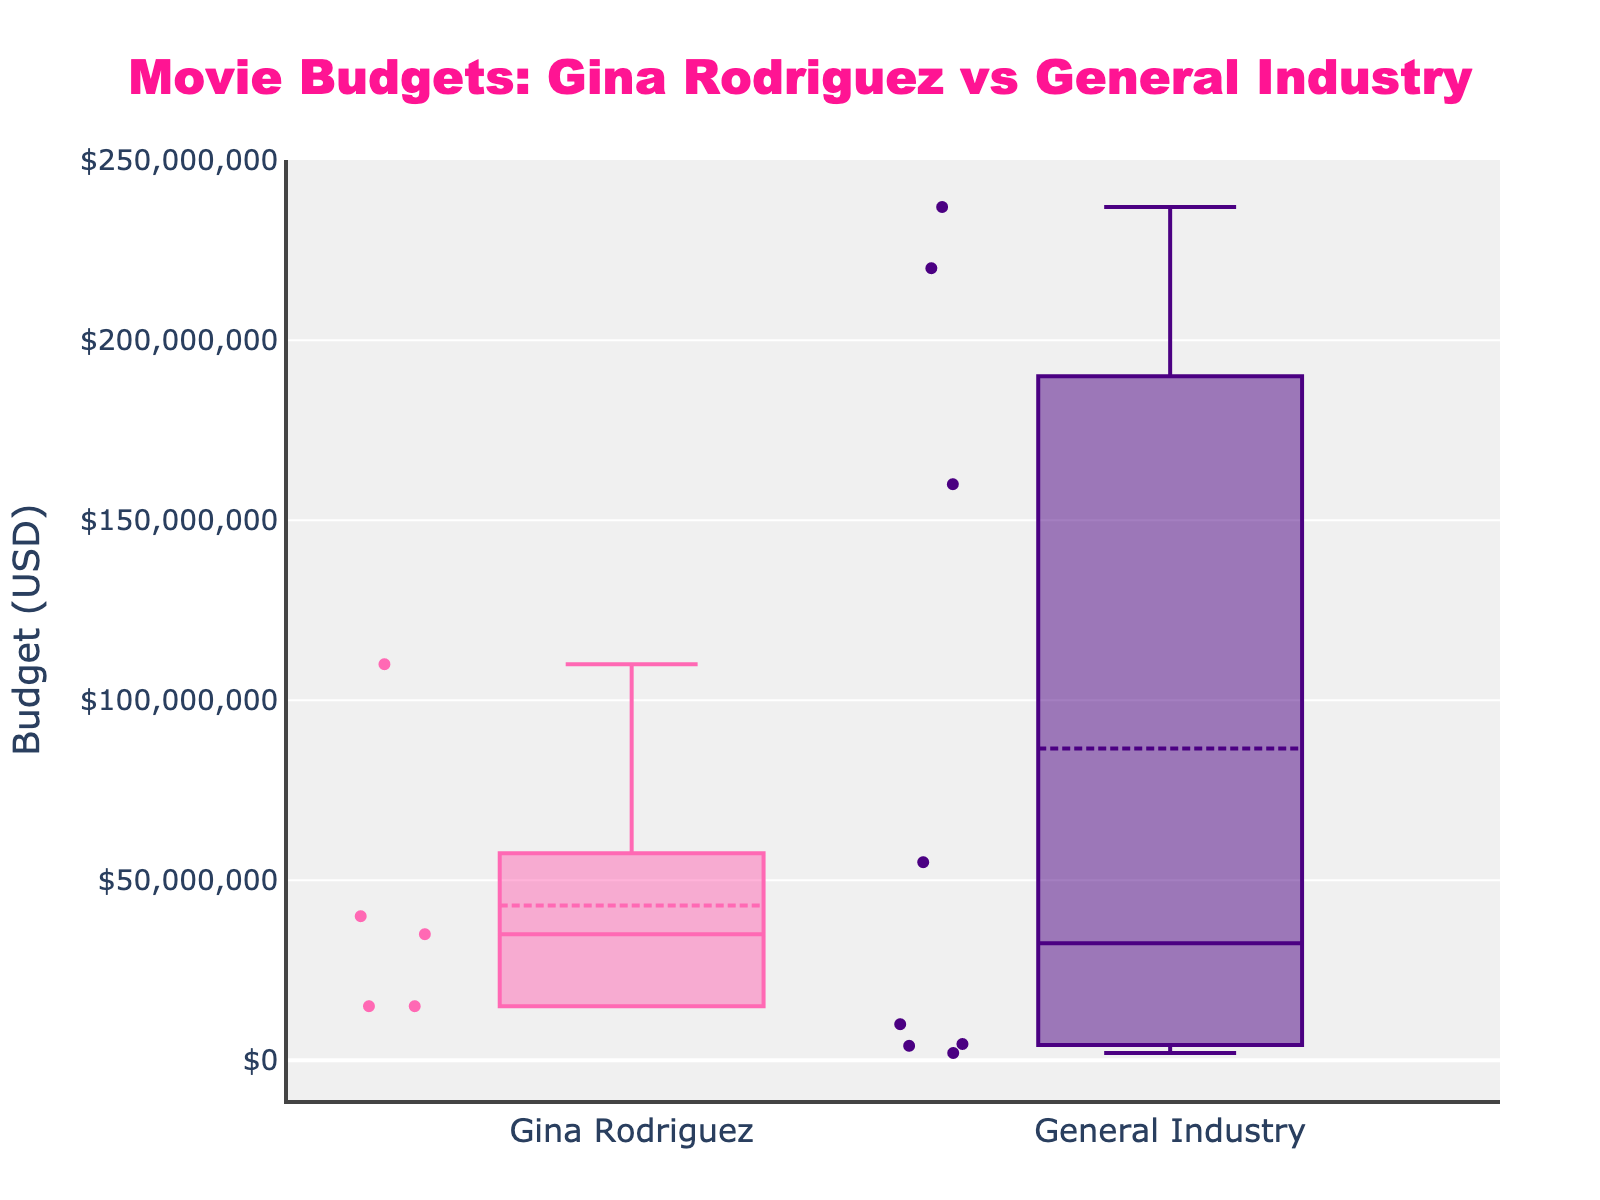How many data points are there for Gina Rodriguez's movie budgets? By counting the number of box points under the label 'Gina Rodriguez', you can determine the number of data points.
Answer: 5 What is the median budget for Gina Rodriguez's movies? The median value corresponds to the middle line inside the box of the 'Gina Rodriguez' group.
Answer: $15,000,000 What is the range of movie budgets in the general industry? The range is calculated by subtracting the lowest budget value (bottom whisker) from the highest budget value (top whisker) in the 'General Industry' group.
Answer: $235,000,000 Which category has the higher average budget? The average budget is indicated by the dashed line inside the box. Compare the dashed lines of 'Gina Rodriguez' and 'General Industry'.
Answer: General Industry What is the interquartile range (IQR) for the general industry movie budgets? The IQR is the distance between the first quartile (bottom of the box) and the third quartile (top of the box) for the 'General Industry' group.
Answer: $156,000,000 How many outliers are there in Gina Rodriguez's movie budgets? Outliers are represented by points outside the whiskers of the box plot. Check for these points in the 'Gina Rodriguez' category.
Answer: 0 What is the difference between the highest budgets for Gina Rodriguez's movies and general industry movies? Identify the highest budget of each category by finding the top whisker and subtracting the higher value from the general industry from Gina Rodriguez's highest budget.
Answer: $127,000,000 Is there any Gina Rodriguez movie with a budget above the general industry median? Compare the budget values of Gina Rodriguez's movies with the median budget (middle line in the box) of the general industry and check if any budget exceeds this value.
Answer: No Which category shows a wider spread of movie budgets? The spread can be determined by looking at the total range from the bottom whisker to the top whisker for 'Gina Rodriguez' and 'General Industry'. The wider spread corresponds to the 'General Industry'.
Answer: General Industry What is the budget for Gina Rodriguez's most expensive movie? Identify the top whisker in the 'Gina Rodriguez' category box plot, which represents the highest budget.
Answer: $110,000,000 